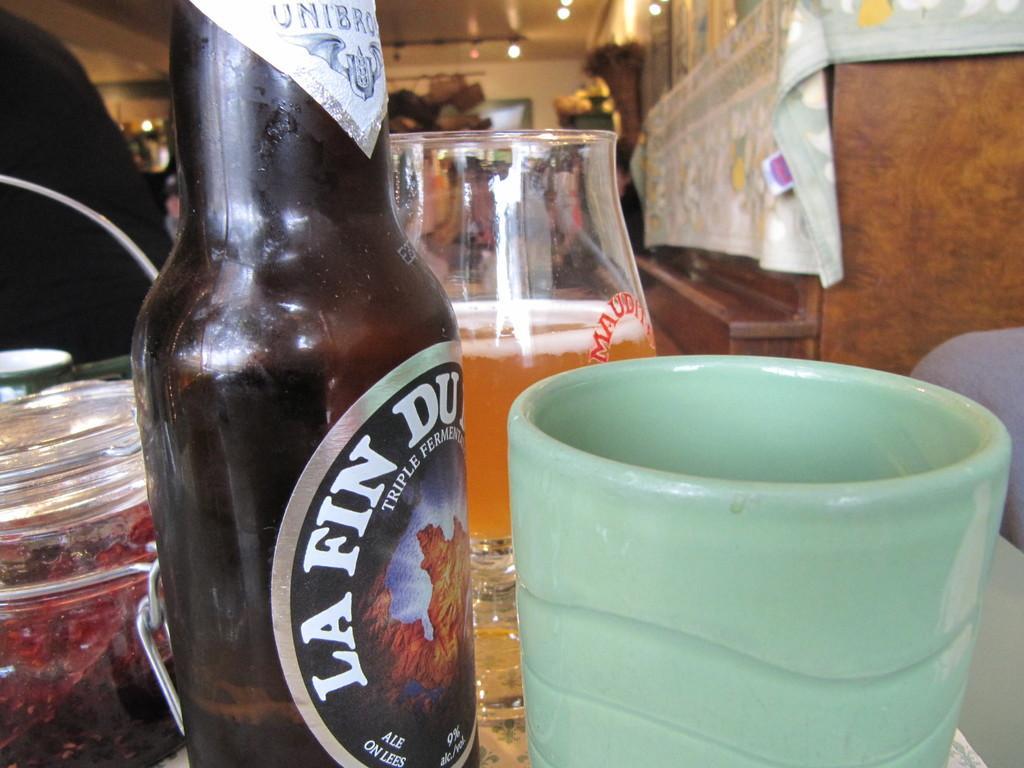Could you give a brief overview of what you see in this image? A wine bottle,a glass and a cup are placed on a table. 